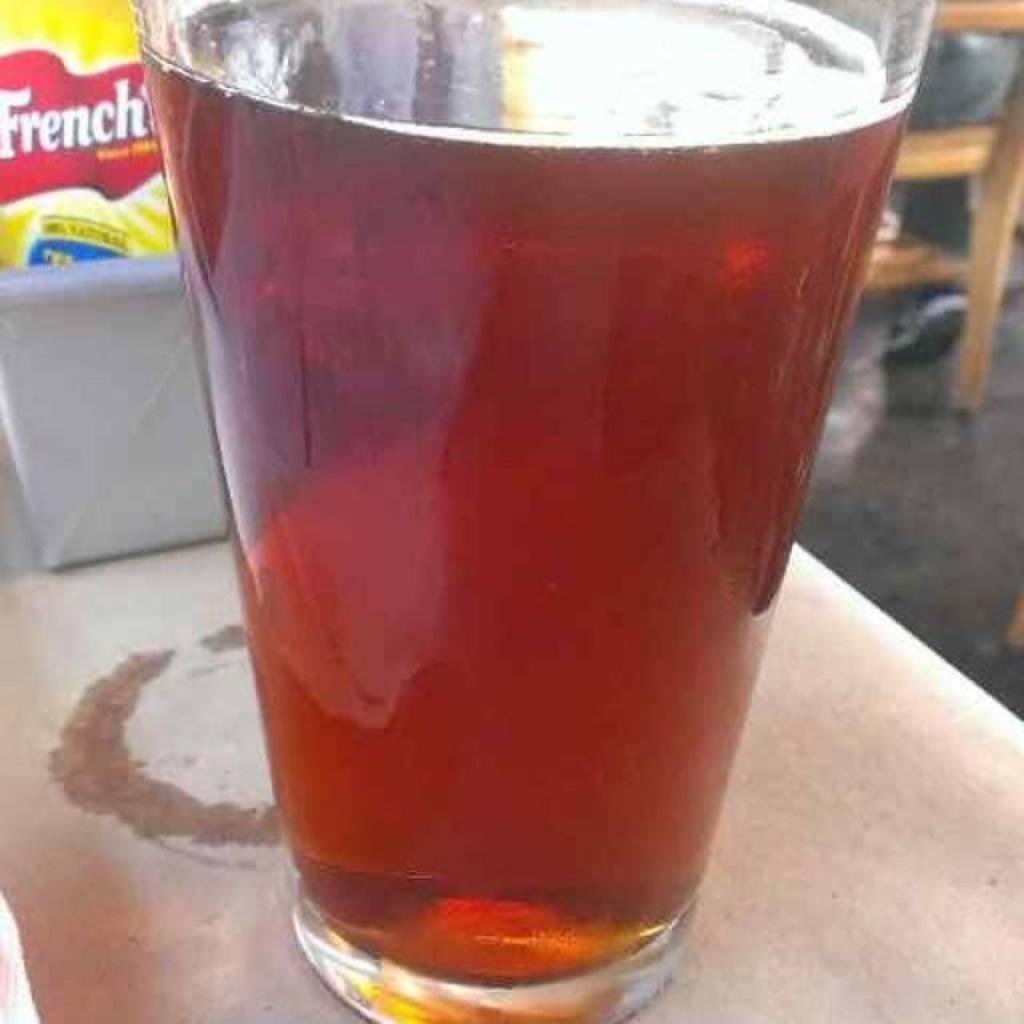In one or two sentences, can you explain what this image depicts? In this image we can see a glass of drink, and a packet in the box, which are on the table, also we can see the chair. 